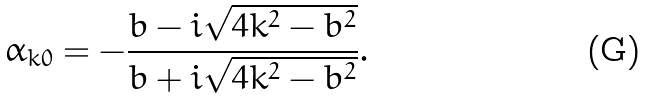Convert formula to latex. <formula><loc_0><loc_0><loc_500><loc_500>\alpha _ { k 0 } = - \frac { b - i \sqrt { 4 k ^ { 2 } - b ^ { 2 } } } { b + i \sqrt { 4 k ^ { 2 } - b ^ { 2 } } } .</formula> 